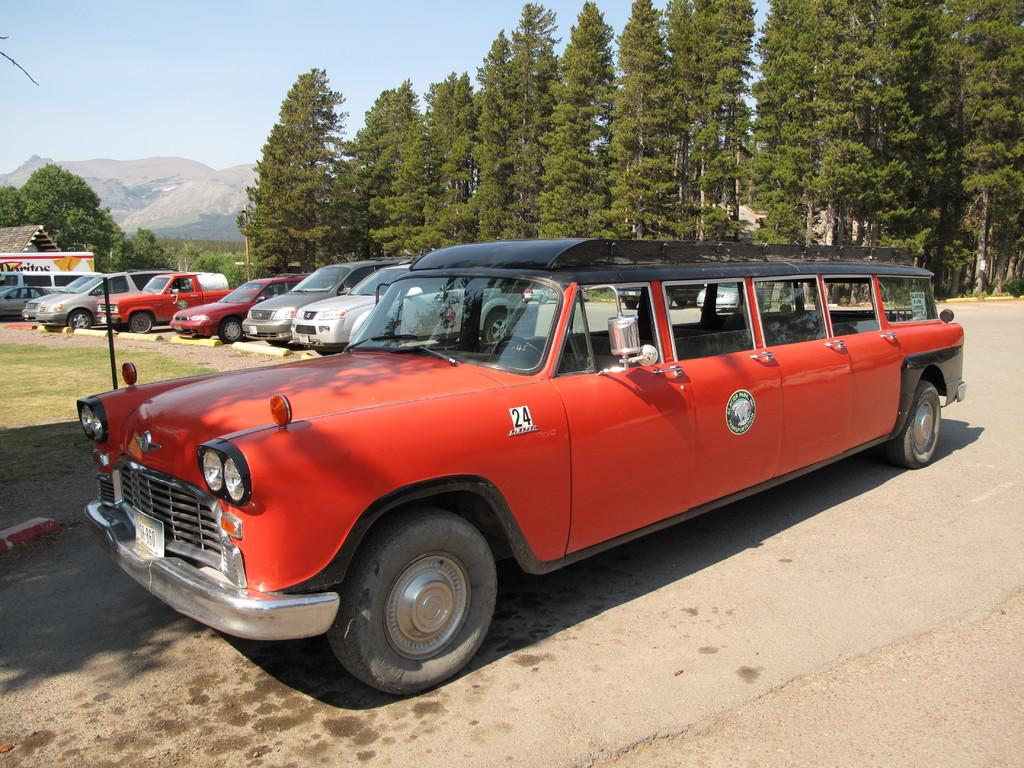What type of vehicles can be seen in the image? There are cars in the image. What other objects or features are present in the image? There are trees and a road in the image. What part of the natural environment is visible in the image? The sky is visible in the image. What type of wax can be seen melting on the cars in the image? There is no wax present in the image, and therefore no wax can be seen melting on the cars. 